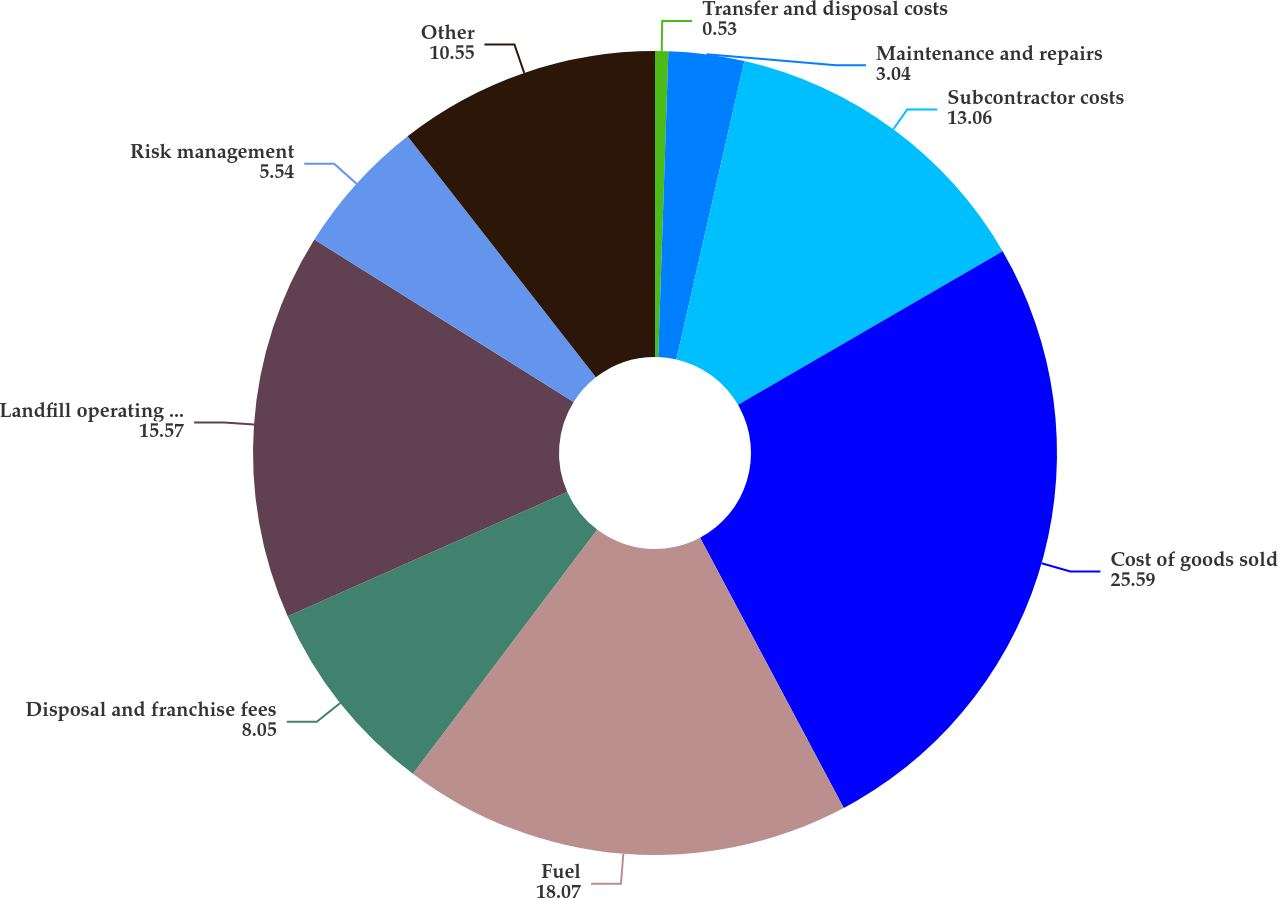<chart> <loc_0><loc_0><loc_500><loc_500><pie_chart><fcel>Transfer and disposal costs<fcel>Maintenance and repairs<fcel>Subcontractor costs<fcel>Cost of goods sold<fcel>Fuel<fcel>Disposal and franchise fees<fcel>Landfill operating costs<fcel>Risk management<fcel>Other<nl><fcel>0.53%<fcel>3.04%<fcel>13.06%<fcel>25.59%<fcel>18.07%<fcel>8.05%<fcel>15.57%<fcel>5.54%<fcel>10.55%<nl></chart> 